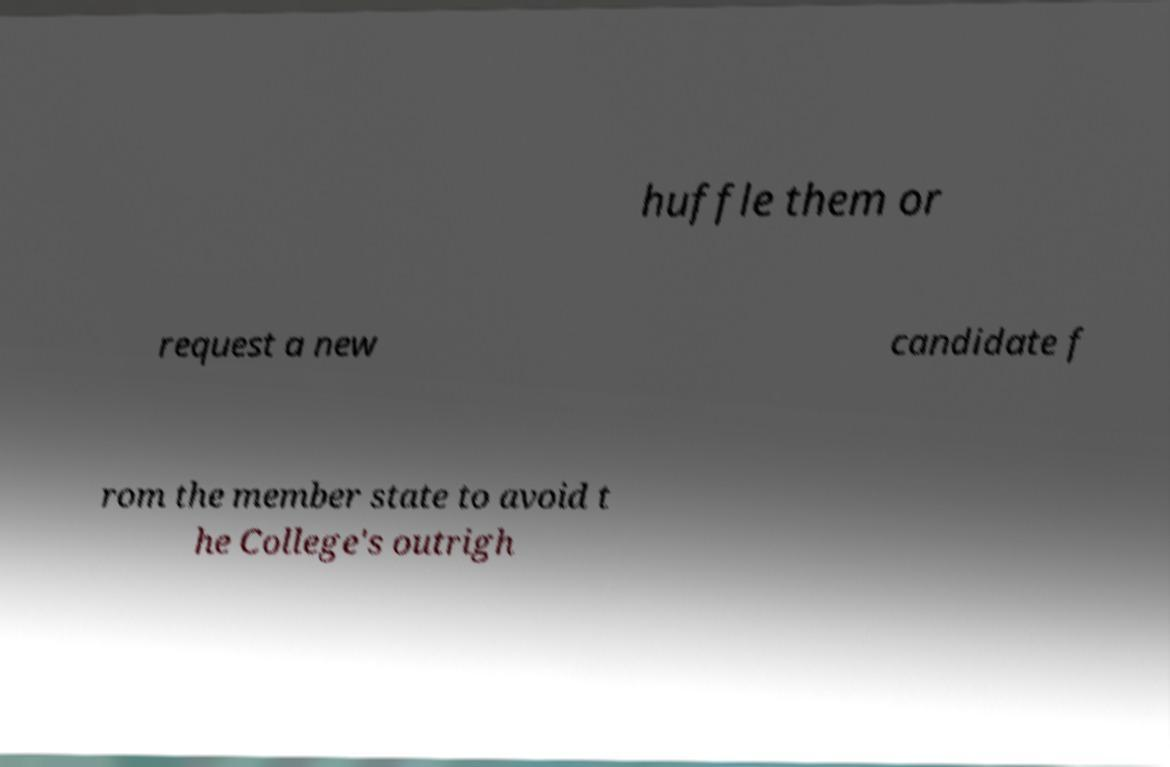Could you extract and type out the text from this image? huffle them or request a new candidate f rom the member state to avoid t he College's outrigh 